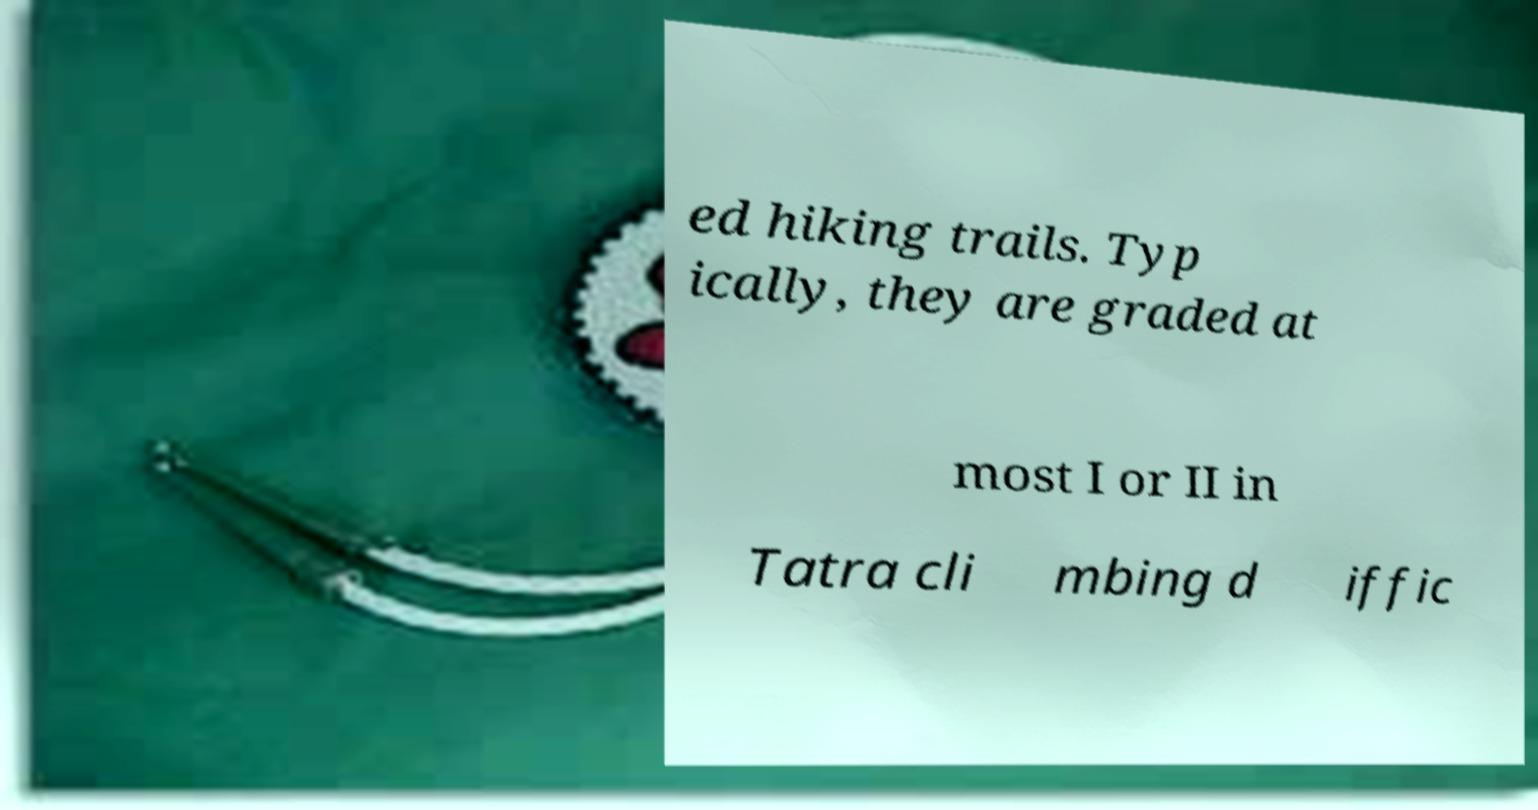Please identify and transcribe the text found in this image. ed hiking trails. Typ ically, they are graded at most I or II in Tatra cli mbing d iffic 